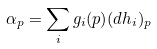<formula> <loc_0><loc_0><loc_500><loc_500>\alpha _ { p } = \sum _ { i } g _ { i } ( p ) ( d h _ { i } ) _ { p }</formula> 